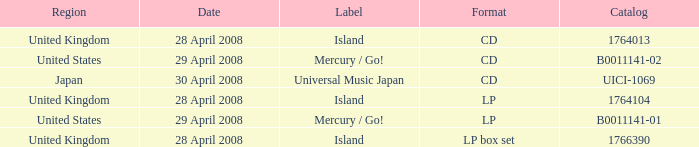What is the Region of the 1766390 Catalog? United Kingdom. Could you parse the entire table? {'header': ['Region', 'Date', 'Label', 'Format', 'Catalog'], 'rows': [['United Kingdom', '28 April 2008', 'Island', 'CD', '1764013'], ['United States', '29 April 2008', 'Mercury / Go!', 'CD', 'B0011141-02'], ['Japan', '30 April 2008', 'Universal Music Japan', 'CD', 'UICI-1069'], ['United Kingdom', '28 April 2008', 'Island', 'LP', '1764104'], ['United States', '29 April 2008', 'Mercury / Go!', 'LP', 'B0011141-01'], ['United Kingdom', '28 April 2008', 'Island', 'LP box set', '1766390']]} 